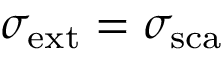<formula> <loc_0><loc_0><loc_500><loc_500>\sigma _ { e x t } = \sigma _ { s c a }</formula> 